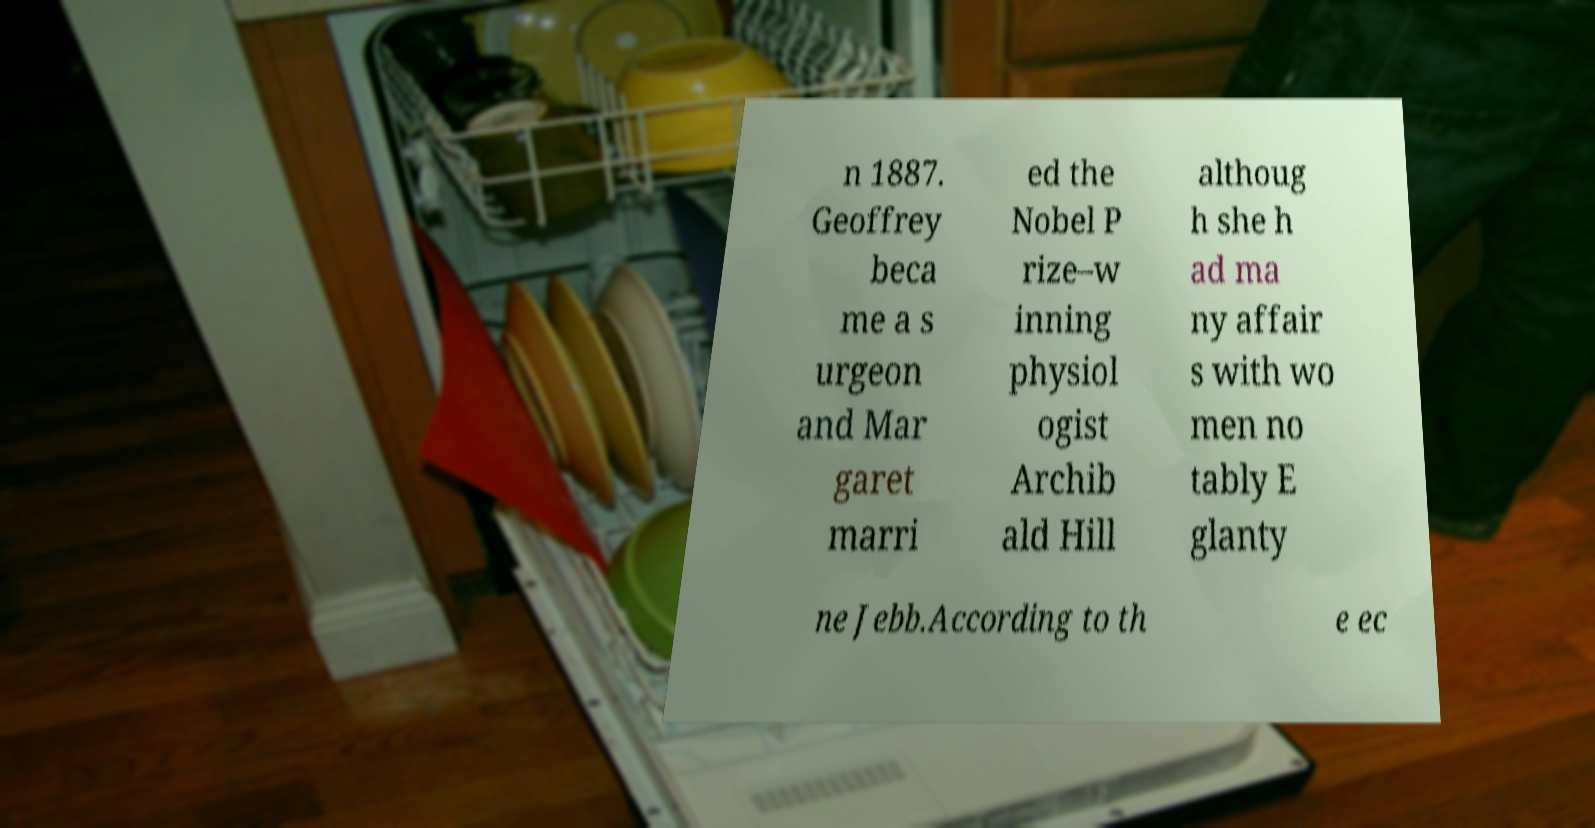Can you read and provide the text displayed in the image?This photo seems to have some interesting text. Can you extract and type it out for me? n 1887. Geoffrey beca me a s urgeon and Mar garet marri ed the Nobel P rize–w inning physiol ogist Archib ald Hill althoug h she h ad ma ny affair s with wo men no tably E glanty ne Jebb.According to th e ec 